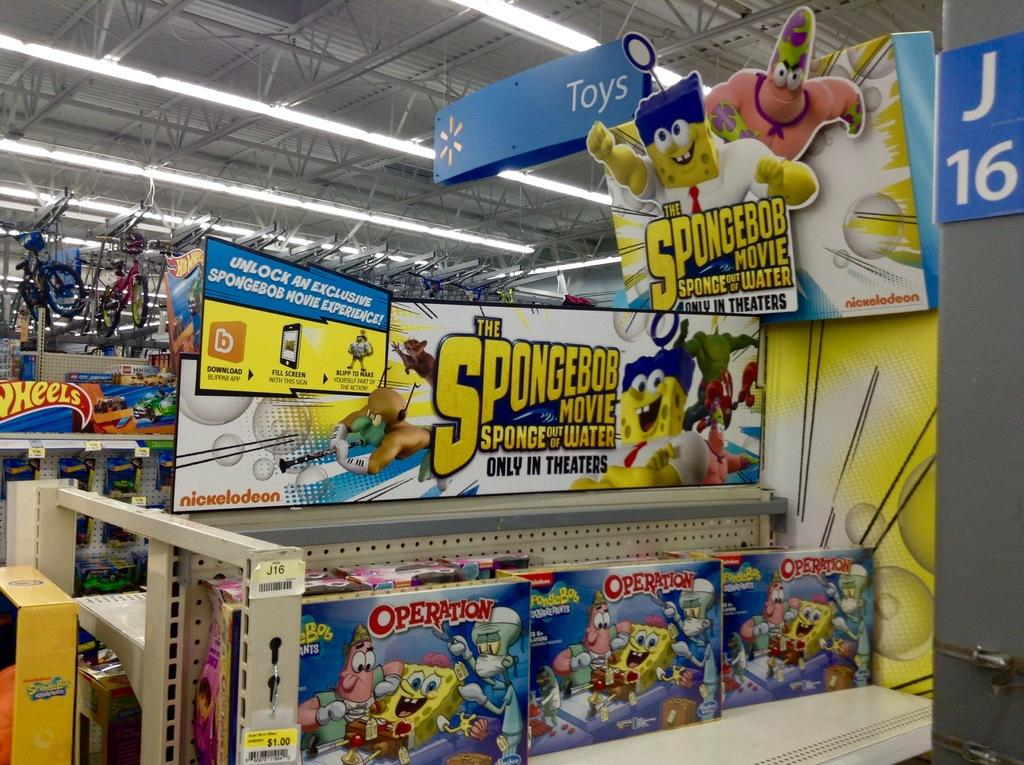<image>
Share a concise interpretation of the image provided. Toy display at Walmart with toys from spongebob the movie. 